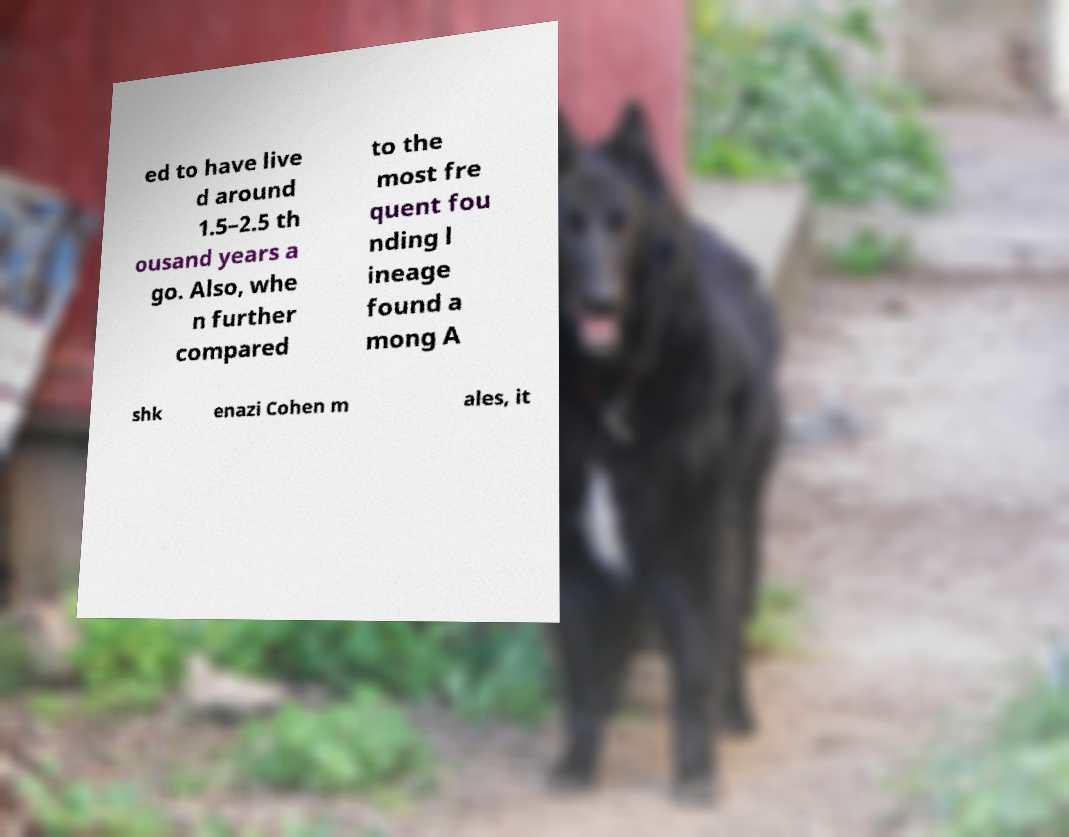What messages or text are displayed in this image? I need them in a readable, typed format. ed to have live d around 1.5–2.5 th ousand years a go. Also, whe n further compared to the most fre quent fou nding l ineage found a mong A shk enazi Cohen m ales, it 